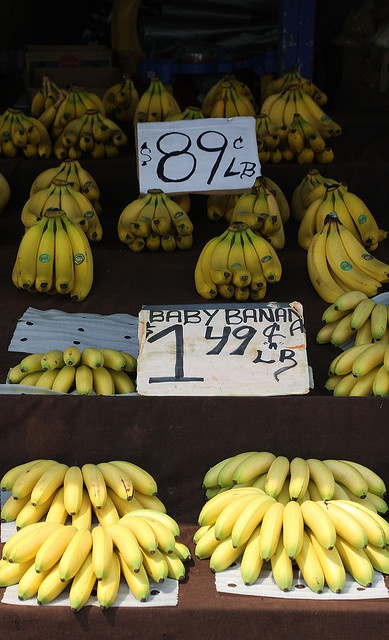Describe the objects in this image and their specific colors. I can see banana in black, olive, and khaki tones, banana in black, khaki, gold, and olive tones, banana in black, tan, khaki, and olive tones, banana in black and olive tones, and banana in black and olive tones in this image. 